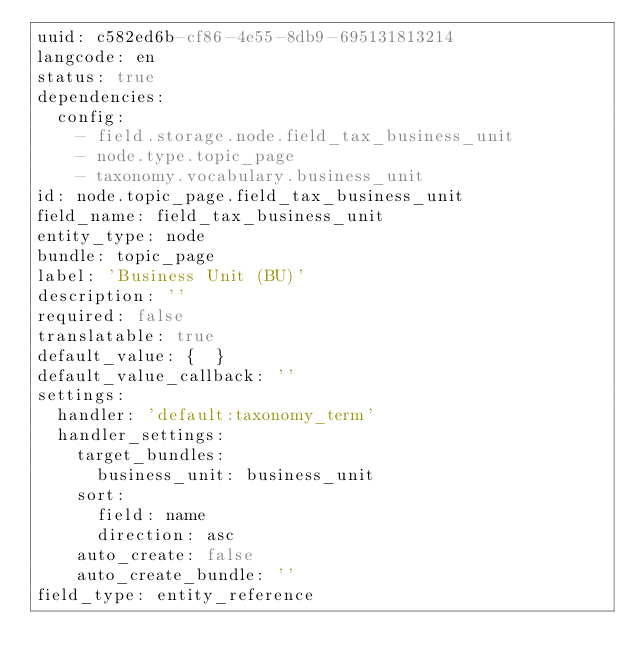<code> <loc_0><loc_0><loc_500><loc_500><_YAML_>uuid: c582ed6b-cf86-4e55-8db9-695131813214
langcode: en
status: true
dependencies:
  config:
    - field.storage.node.field_tax_business_unit
    - node.type.topic_page
    - taxonomy.vocabulary.business_unit
id: node.topic_page.field_tax_business_unit
field_name: field_tax_business_unit
entity_type: node
bundle: topic_page
label: 'Business Unit (BU)'
description: ''
required: false
translatable: true
default_value: {  }
default_value_callback: ''
settings:
  handler: 'default:taxonomy_term'
  handler_settings:
    target_bundles:
      business_unit: business_unit
    sort:
      field: name
      direction: asc
    auto_create: false
    auto_create_bundle: ''
field_type: entity_reference
</code> 